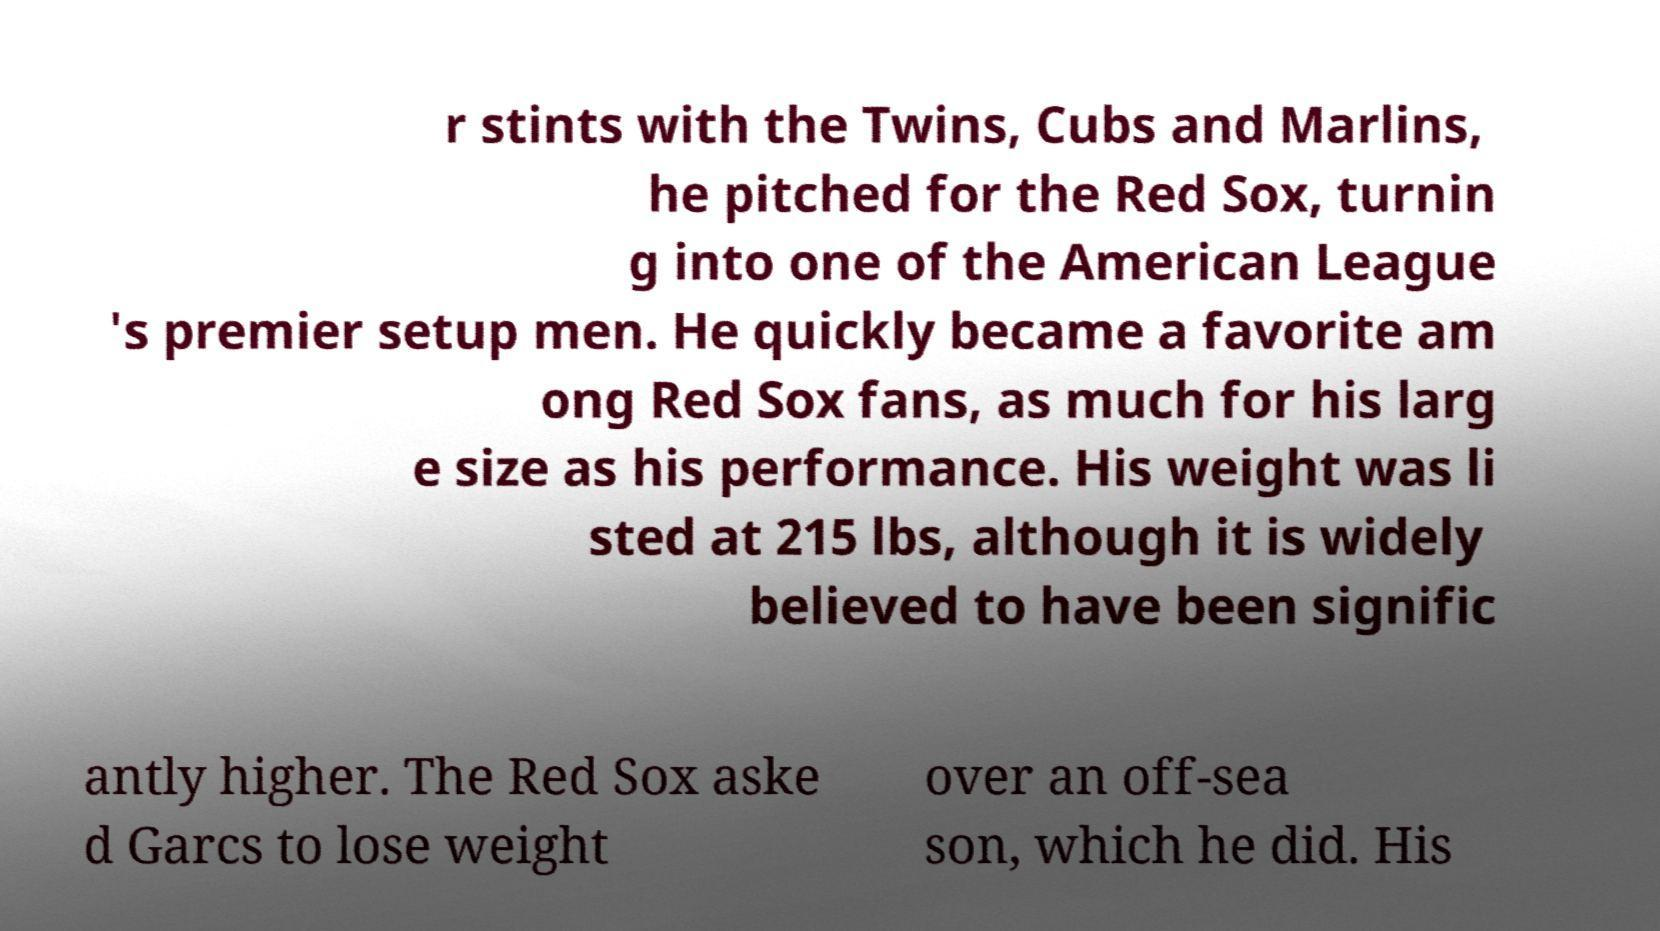For documentation purposes, I need the text within this image transcribed. Could you provide that? r stints with the Twins, Cubs and Marlins, he pitched for the Red Sox, turnin g into one of the American League 's premier setup men. He quickly became a favorite am ong Red Sox fans, as much for his larg e size as his performance. His weight was li sted at 215 lbs, although it is widely believed to have been signific antly higher. The Red Sox aske d Garcs to lose weight over an off-sea son, which he did. His 